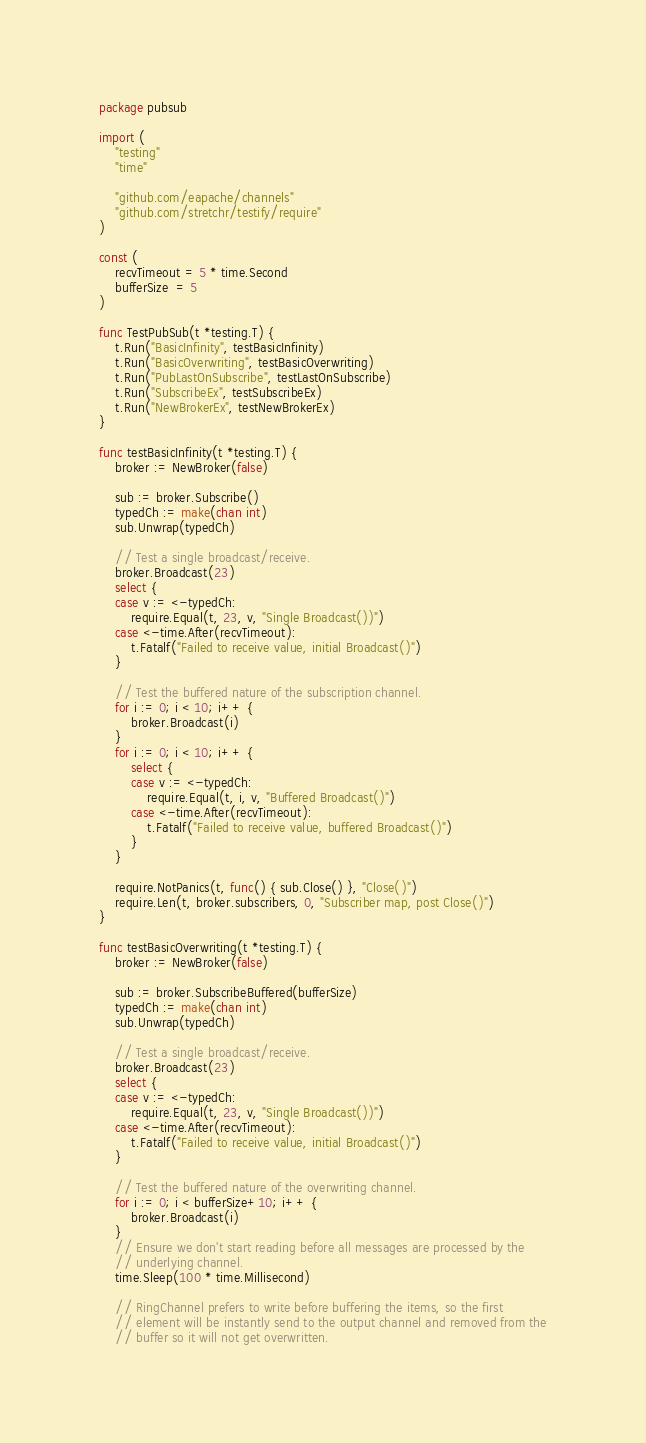Convert code to text. <code><loc_0><loc_0><loc_500><loc_500><_Go_>package pubsub

import (
	"testing"
	"time"

	"github.com/eapache/channels"
	"github.com/stretchr/testify/require"
)

const (
	recvTimeout = 5 * time.Second
	bufferSize  = 5
)

func TestPubSub(t *testing.T) {
	t.Run("BasicInfinity", testBasicInfinity)
	t.Run("BasicOverwriting", testBasicOverwriting)
	t.Run("PubLastOnSubscribe", testLastOnSubscribe)
	t.Run("SubscribeEx", testSubscribeEx)
	t.Run("NewBrokerEx", testNewBrokerEx)
}

func testBasicInfinity(t *testing.T) {
	broker := NewBroker(false)

	sub := broker.Subscribe()
	typedCh := make(chan int)
	sub.Unwrap(typedCh)

	// Test a single broadcast/receive.
	broker.Broadcast(23)
	select {
	case v := <-typedCh:
		require.Equal(t, 23, v, "Single Broadcast())")
	case <-time.After(recvTimeout):
		t.Fatalf("Failed to receive value, initial Broadcast()")
	}

	// Test the buffered nature of the subscription channel.
	for i := 0; i < 10; i++ {
		broker.Broadcast(i)
	}
	for i := 0; i < 10; i++ {
		select {
		case v := <-typedCh:
			require.Equal(t, i, v, "Buffered Broadcast()")
		case <-time.After(recvTimeout):
			t.Fatalf("Failed to receive value, buffered Broadcast()")
		}
	}

	require.NotPanics(t, func() { sub.Close() }, "Close()")
	require.Len(t, broker.subscribers, 0, "Subscriber map, post Close()")
}

func testBasicOverwriting(t *testing.T) {
	broker := NewBroker(false)

	sub := broker.SubscribeBuffered(bufferSize)
	typedCh := make(chan int)
	sub.Unwrap(typedCh)

	// Test a single broadcast/receive.
	broker.Broadcast(23)
	select {
	case v := <-typedCh:
		require.Equal(t, 23, v, "Single Broadcast())")
	case <-time.After(recvTimeout):
		t.Fatalf("Failed to receive value, initial Broadcast()")
	}

	// Test the buffered nature of the overwriting channel.
	for i := 0; i < bufferSize+10; i++ {
		broker.Broadcast(i)
	}
	// Ensure we don't start reading before all messages are processed by the
	// underlying channel.
	time.Sleep(100 * time.Millisecond)

	// RingChannel prefers to write before buffering the items, so the first
	// element will be instantly send to the output channel and removed from the
	// buffer so it will not get overwritten.</code> 